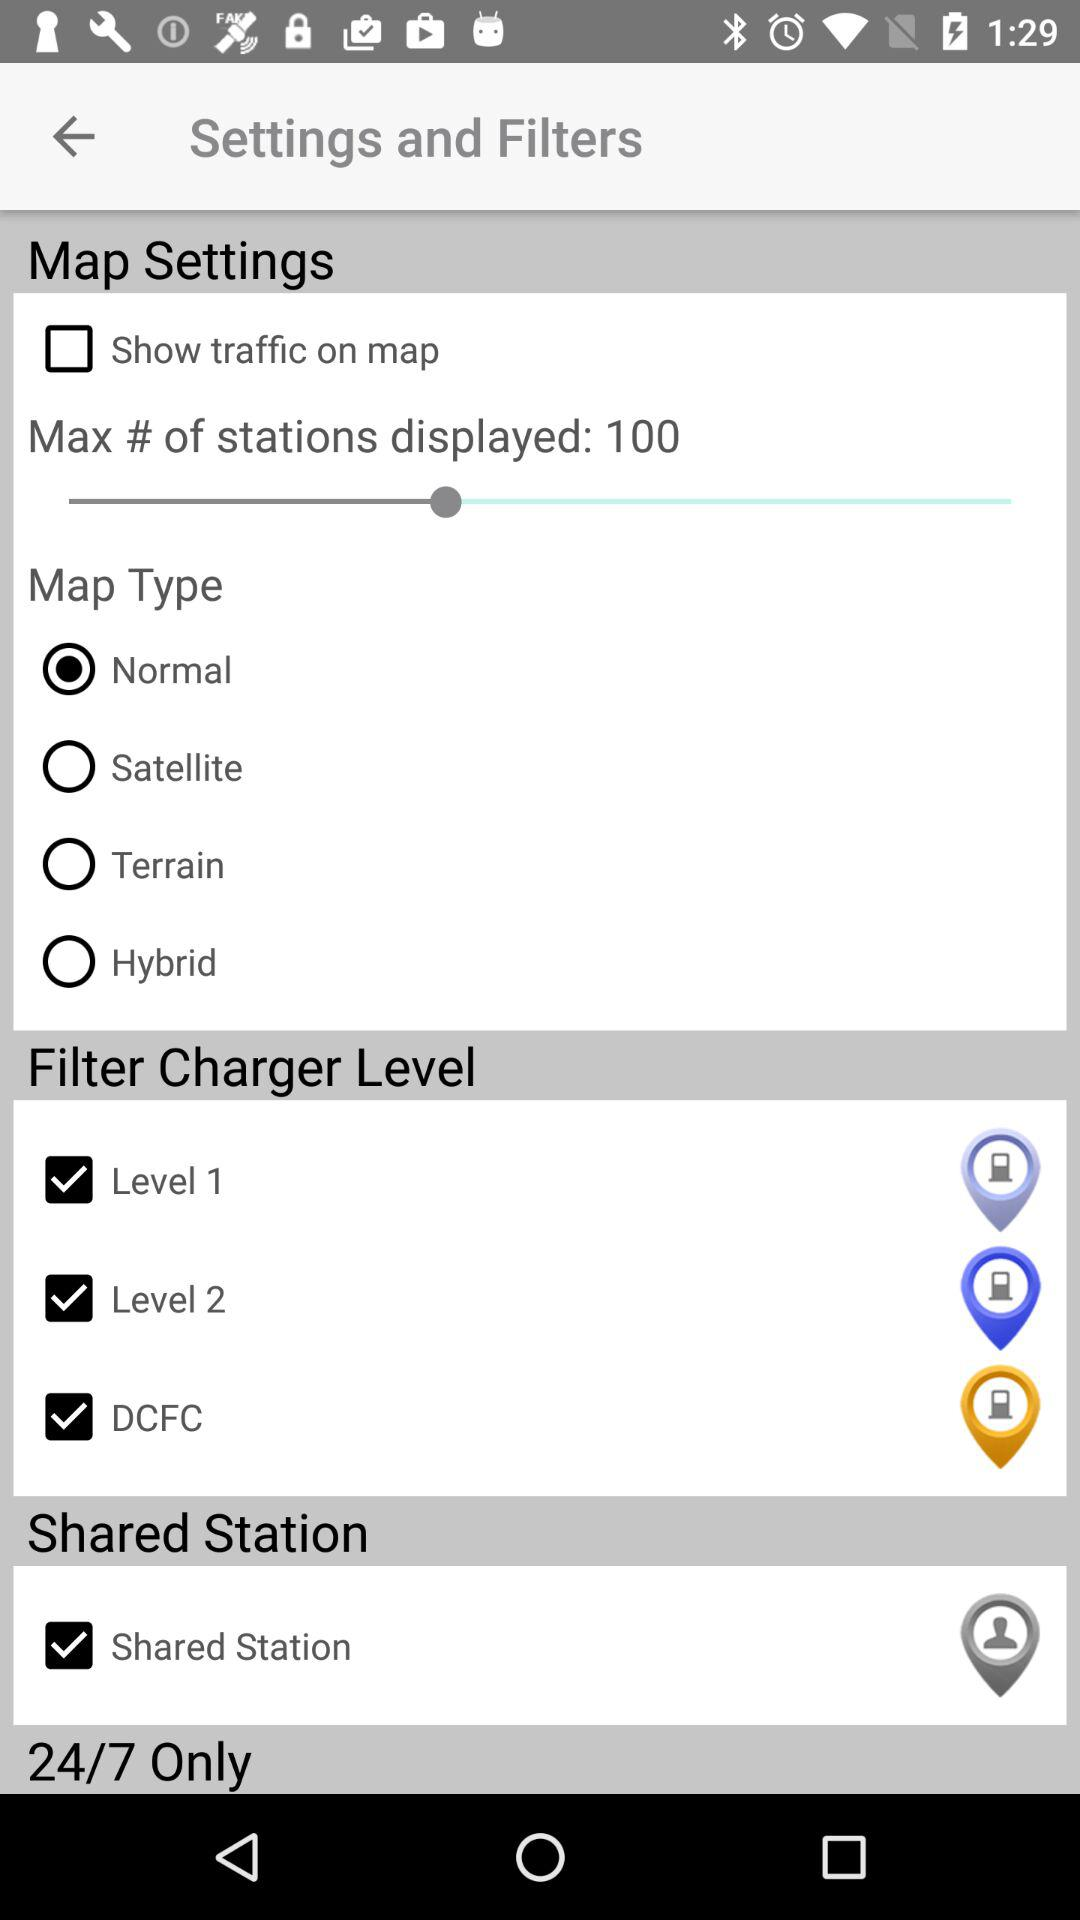What is the status of "Show traffic on map" in "Map Settings"? The status is "off". 